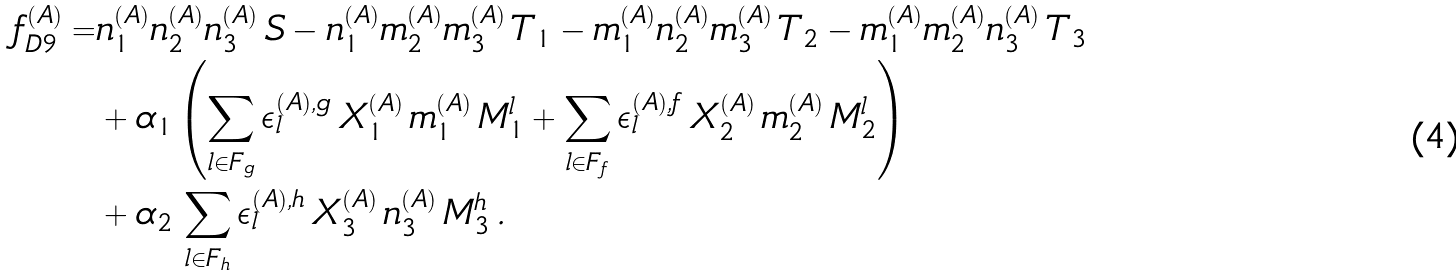<formula> <loc_0><loc_0><loc_500><loc_500>f _ { D 9 } ^ { ( A ) } = & n _ { 1 } ^ { ( A ) } n _ { 2 } ^ { ( A ) } n _ { 3 } ^ { ( A ) } \, S - n _ { 1 } ^ { ( A ) } m _ { 2 } ^ { ( A ) } m _ { 3 } ^ { ( A ) } \, T _ { 1 } - m _ { 1 } ^ { ( A ) } n _ { 2 } ^ { ( A ) } m _ { 3 } ^ { ( A ) } \, T _ { 2 } - m _ { 1 } ^ { ( A ) } m _ { 2 } ^ { ( A ) } n _ { 3 } ^ { ( A ) } \, T _ { 3 } \\ & + \alpha _ { 1 } \left ( \sum _ { l \in F _ { g } } \epsilon _ { l } ^ { ( A ) , g } \, X _ { 1 } ^ { ( A ) } \, m _ { 1 } ^ { ( A ) } \, M _ { 1 } ^ { l } + \sum _ { l \in F _ { f } } \epsilon _ { l } ^ { ( A ) , f } \, X _ { 2 } ^ { ( A ) } \, m _ { 2 } ^ { ( A ) } \, M _ { 2 } ^ { l } \right ) \\ & + \alpha _ { 2 } \, \sum _ { l \in F _ { h } } \epsilon _ { l } ^ { ( A ) , h } \, X _ { 3 } ^ { ( A ) } \, n _ { 3 } ^ { ( A ) } \, M _ { 3 } ^ { h } \, .</formula> 